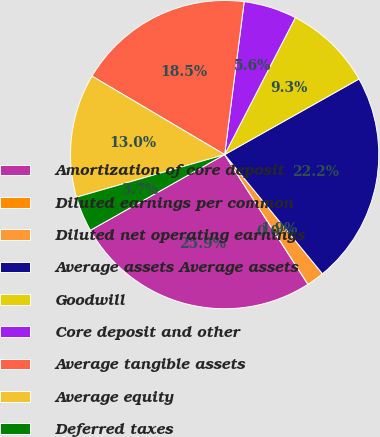<chart> <loc_0><loc_0><loc_500><loc_500><pie_chart><fcel>Amortization of core deposit<fcel>Diluted earnings per common<fcel>Diluted net operating earnings<fcel>Average assets Average assets<fcel>Goodwill<fcel>Core deposit and other<fcel>Average tangible assets<fcel>Average equity<fcel>Deferred taxes<nl><fcel>25.92%<fcel>0.0%<fcel>1.85%<fcel>22.22%<fcel>9.26%<fcel>5.56%<fcel>18.52%<fcel>12.96%<fcel>3.71%<nl></chart> 